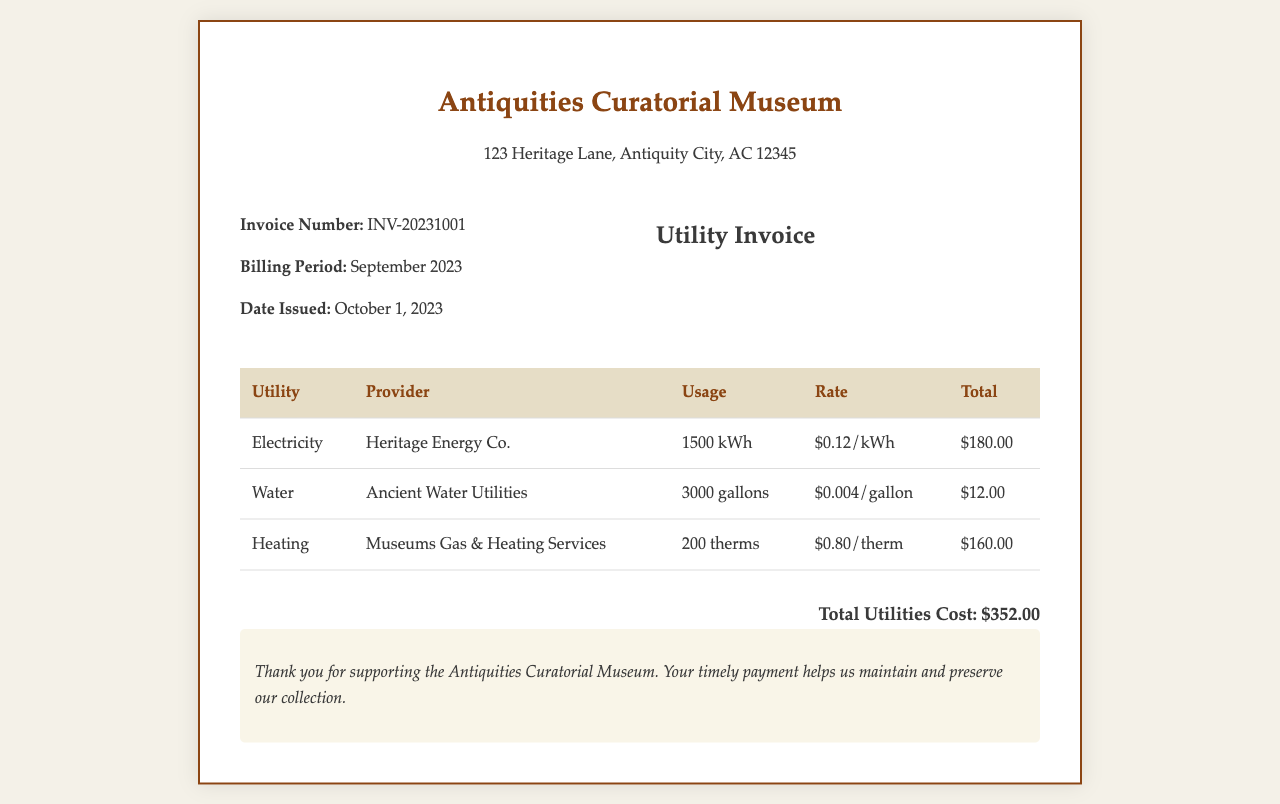What is the invoice number? The invoice number is listed under the invoice details section of the document.
Answer: INV-20231001 Who is the provider for electricity? The provider name for electricity is mentioned in the utility breakdown table.
Answer: Heritage Energy Co What is the total cost for heating? The total cost for heating is calculated based on the usage and rate, which is shown in the utility breakdown.
Answer: $160.00 How many gallons of water were used? The amount of water used is provided in the breakdown table under the usage column for the water utility.
Answer: 3000 gallons What was the billing period for this invoice? The billing period is specified in the invoice details section.
Answer: September 2023 What is the rate per therm for heating? The rate for heating is indicated next to the heating usage in the utility breakdown.
Answer: $0.80/therm What is the total utilities cost? The total utilities cost is provided at the end of the utility breakdown segment.
Answer: $352.00 Which company provides water utility services? The company providing water utility services is mentioned in the utility breakdown table.
Answer: Ancient Water Utilities How many kWh of electricity were used? The usage for electricity is specified in the breakdown of utilities.
Answer: 1500 kWh 